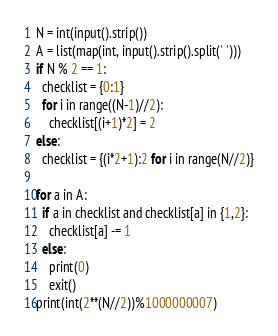<code> <loc_0><loc_0><loc_500><loc_500><_Python_>N = int(input().strip())
A = list(map(int, input().strip().split(' ')))
if N % 2 == 1:
  checklist = {0:1}
  for i in range((N-1)//2):
    checklist[(i+1)*2] = 2
else:
  checklist = {(i*2+1):2 for i in range(N//2)}

for a in A:
  if a in checklist and checklist[a] in {1,2}:
    checklist[a] -= 1
  else:
    print(0)
    exit()
print(int(2**(N//2))%1000000007)</code> 